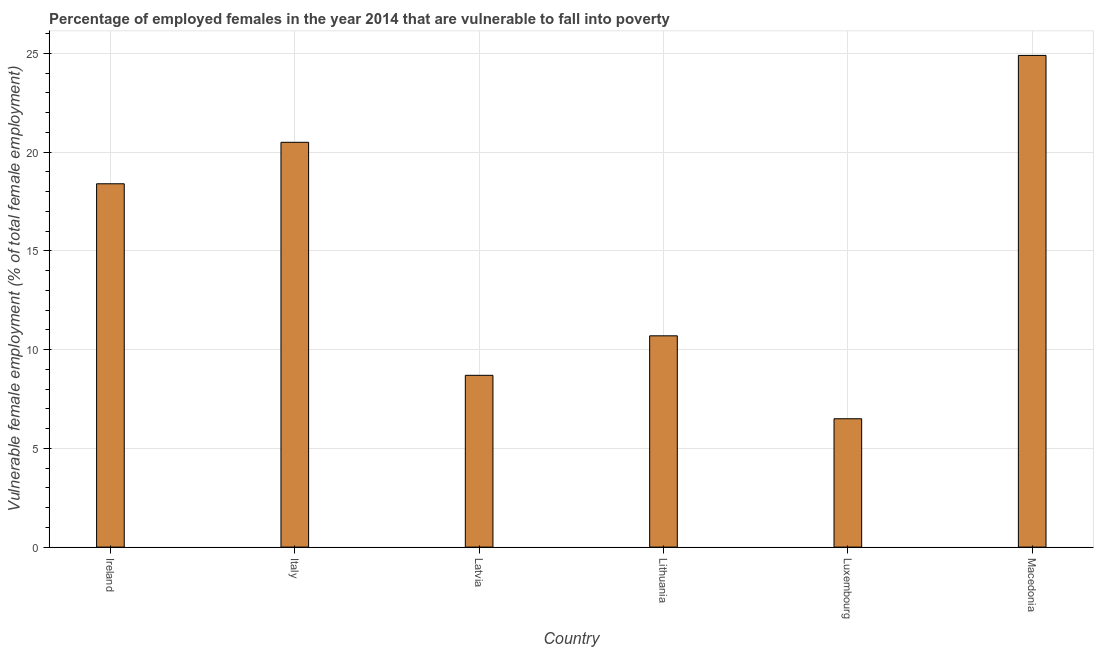Does the graph contain any zero values?
Provide a succinct answer. No. Does the graph contain grids?
Your answer should be compact. Yes. What is the title of the graph?
Keep it short and to the point. Percentage of employed females in the year 2014 that are vulnerable to fall into poverty. What is the label or title of the X-axis?
Offer a terse response. Country. What is the label or title of the Y-axis?
Your response must be concise. Vulnerable female employment (% of total female employment). Across all countries, what is the maximum percentage of employed females who are vulnerable to fall into poverty?
Provide a short and direct response. 24.9. In which country was the percentage of employed females who are vulnerable to fall into poverty maximum?
Your response must be concise. Macedonia. In which country was the percentage of employed females who are vulnerable to fall into poverty minimum?
Offer a very short reply. Luxembourg. What is the sum of the percentage of employed females who are vulnerable to fall into poverty?
Offer a very short reply. 89.7. What is the difference between the percentage of employed females who are vulnerable to fall into poverty in Lithuania and Macedonia?
Your answer should be compact. -14.2. What is the average percentage of employed females who are vulnerable to fall into poverty per country?
Give a very brief answer. 14.95. What is the median percentage of employed females who are vulnerable to fall into poverty?
Provide a succinct answer. 14.55. What is the ratio of the percentage of employed females who are vulnerable to fall into poverty in Lithuania to that in Luxembourg?
Offer a very short reply. 1.65. Is the difference between the percentage of employed females who are vulnerable to fall into poverty in Luxembourg and Macedonia greater than the difference between any two countries?
Provide a short and direct response. Yes. Is the sum of the percentage of employed females who are vulnerable to fall into poverty in Ireland and Macedonia greater than the maximum percentage of employed females who are vulnerable to fall into poverty across all countries?
Your answer should be compact. Yes. What is the difference between the highest and the lowest percentage of employed females who are vulnerable to fall into poverty?
Provide a succinct answer. 18.4. Are all the bars in the graph horizontal?
Your answer should be compact. No. What is the difference between two consecutive major ticks on the Y-axis?
Offer a terse response. 5. Are the values on the major ticks of Y-axis written in scientific E-notation?
Offer a terse response. No. What is the Vulnerable female employment (% of total female employment) in Ireland?
Make the answer very short. 18.4. What is the Vulnerable female employment (% of total female employment) of Italy?
Provide a short and direct response. 20.5. What is the Vulnerable female employment (% of total female employment) of Latvia?
Keep it short and to the point. 8.7. What is the Vulnerable female employment (% of total female employment) in Lithuania?
Offer a very short reply. 10.7. What is the Vulnerable female employment (% of total female employment) in Luxembourg?
Offer a terse response. 6.5. What is the Vulnerable female employment (% of total female employment) of Macedonia?
Your answer should be compact. 24.9. What is the difference between the Vulnerable female employment (% of total female employment) in Italy and Latvia?
Provide a short and direct response. 11.8. What is the difference between the Vulnerable female employment (% of total female employment) in Italy and Macedonia?
Keep it short and to the point. -4.4. What is the difference between the Vulnerable female employment (% of total female employment) in Latvia and Luxembourg?
Provide a short and direct response. 2.2. What is the difference between the Vulnerable female employment (% of total female employment) in Latvia and Macedonia?
Your response must be concise. -16.2. What is the difference between the Vulnerable female employment (% of total female employment) in Lithuania and Luxembourg?
Make the answer very short. 4.2. What is the difference between the Vulnerable female employment (% of total female employment) in Luxembourg and Macedonia?
Offer a terse response. -18.4. What is the ratio of the Vulnerable female employment (% of total female employment) in Ireland to that in Italy?
Make the answer very short. 0.9. What is the ratio of the Vulnerable female employment (% of total female employment) in Ireland to that in Latvia?
Provide a short and direct response. 2.12. What is the ratio of the Vulnerable female employment (% of total female employment) in Ireland to that in Lithuania?
Your answer should be compact. 1.72. What is the ratio of the Vulnerable female employment (% of total female employment) in Ireland to that in Luxembourg?
Offer a terse response. 2.83. What is the ratio of the Vulnerable female employment (% of total female employment) in Ireland to that in Macedonia?
Offer a terse response. 0.74. What is the ratio of the Vulnerable female employment (% of total female employment) in Italy to that in Latvia?
Provide a short and direct response. 2.36. What is the ratio of the Vulnerable female employment (% of total female employment) in Italy to that in Lithuania?
Your answer should be compact. 1.92. What is the ratio of the Vulnerable female employment (% of total female employment) in Italy to that in Luxembourg?
Keep it short and to the point. 3.15. What is the ratio of the Vulnerable female employment (% of total female employment) in Italy to that in Macedonia?
Offer a terse response. 0.82. What is the ratio of the Vulnerable female employment (% of total female employment) in Latvia to that in Lithuania?
Provide a succinct answer. 0.81. What is the ratio of the Vulnerable female employment (% of total female employment) in Latvia to that in Luxembourg?
Your answer should be very brief. 1.34. What is the ratio of the Vulnerable female employment (% of total female employment) in Latvia to that in Macedonia?
Ensure brevity in your answer.  0.35. What is the ratio of the Vulnerable female employment (% of total female employment) in Lithuania to that in Luxembourg?
Keep it short and to the point. 1.65. What is the ratio of the Vulnerable female employment (% of total female employment) in Lithuania to that in Macedonia?
Give a very brief answer. 0.43. What is the ratio of the Vulnerable female employment (% of total female employment) in Luxembourg to that in Macedonia?
Keep it short and to the point. 0.26. 